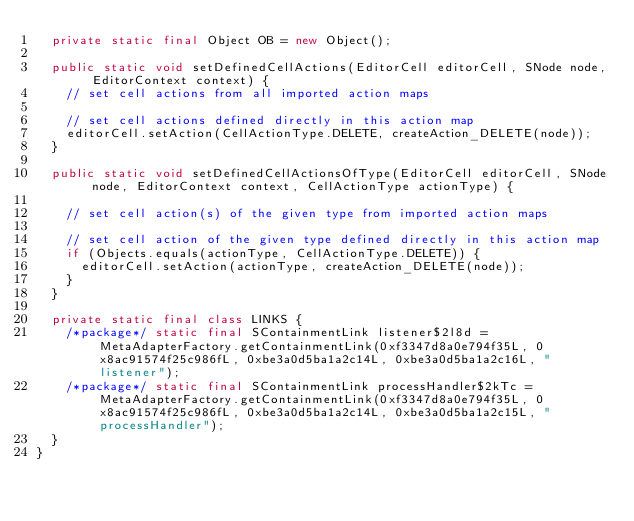<code> <loc_0><loc_0><loc_500><loc_500><_Java_>  private static final Object OB = new Object();

  public static void setDefinedCellActions(EditorCell editorCell, SNode node, EditorContext context) {
    // set cell actions from all imported action maps

    // set cell actions defined directly in this action map
    editorCell.setAction(CellActionType.DELETE, createAction_DELETE(node));
  }

  public static void setDefinedCellActionsOfType(EditorCell editorCell, SNode node, EditorContext context, CellActionType actionType) {

    // set cell action(s) of the given type from imported action maps

    // set cell action of the given type defined directly in this action map
    if (Objects.equals(actionType, CellActionType.DELETE)) {
      editorCell.setAction(actionType, createAction_DELETE(node));
    }
  }

  private static final class LINKS {
    /*package*/ static final SContainmentLink listener$2l8d = MetaAdapterFactory.getContainmentLink(0xf3347d8a0e794f35L, 0x8ac91574f25c986fL, 0xbe3a0d5ba1a2c14L, 0xbe3a0d5ba1a2c16L, "listener");
    /*package*/ static final SContainmentLink processHandler$2kTc = MetaAdapterFactory.getContainmentLink(0xf3347d8a0e794f35L, 0x8ac91574f25c986fL, 0xbe3a0d5ba1a2c14L, 0xbe3a0d5ba1a2c15L, "processHandler");
  }
}
</code> 